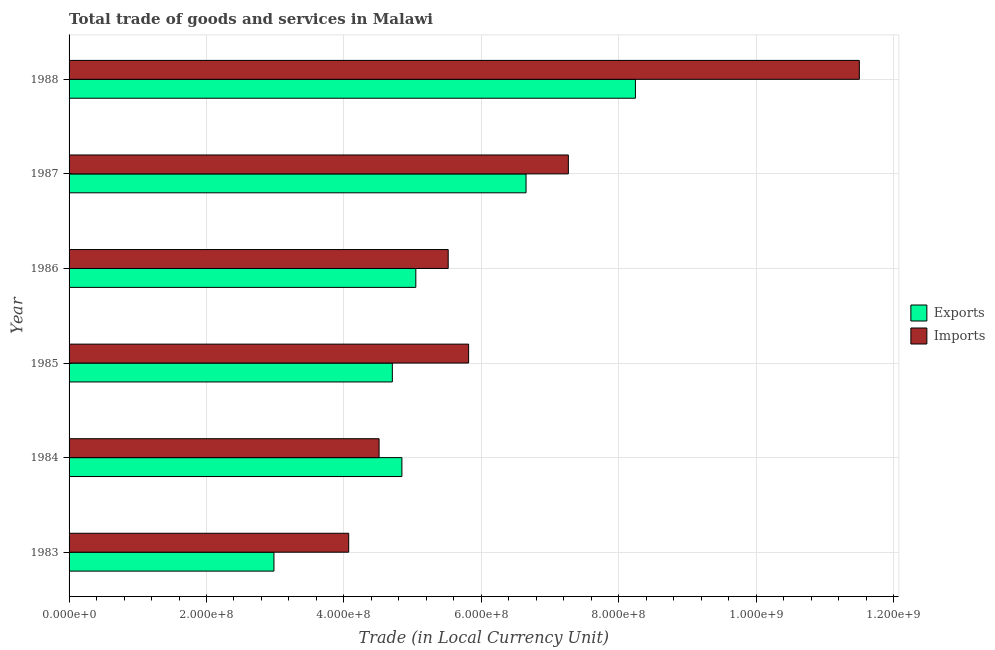Are the number of bars per tick equal to the number of legend labels?
Provide a short and direct response. Yes. Are the number of bars on each tick of the Y-axis equal?
Provide a succinct answer. Yes. How many bars are there on the 4th tick from the bottom?
Provide a succinct answer. 2. In how many cases, is the number of bars for a given year not equal to the number of legend labels?
Keep it short and to the point. 0. What is the imports of goods and services in 1987?
Your response must be concise. 7.27e+08. Across all years, what is the maximum imports of goods and services?
Provide a short and direct response. 1.15e+09. Across all years, what is the minimum export of goods and services?
Provide a succinct answer. 2.98e+08. What is the total imports of goods and services in the graph?
Provide a succinct answer. 3.87e+09. What is the difference between the imports of goods and services in 1987 and that in 1988?
Keep it short and to the point. -4.24e+08. What is the difference between the export of goods and services in 1987 and the imports of goods and services in 1984?
Keep it short and to the point. 2.14e+08. What is the average imports of goods and services per year?
Your answer should be compact. 6.45e+08. In the year 1983, what is the difference between the imports of goods and services and export of goods and services?
Keep it short and to the point. 1.09e+08. What is the ratio of the imports of goods and services in 1983 to that in 1987?
Provide a succinct answer. 0.56. Is the imports of goods and services in 1984 less than that in 1988?
Provide a succinct answer. Yes. What is the difference between the highest and the second highest imports of goods and services?
Your answer should be very brief. 4.24e+08. What is the difference between the highest and the lowest export of goods and services?
Your response must be concise. 5.26e+08. In how many years, is the imports of goods and services greater than the average imports of goods and services taken over all years?
Your answer should be very brief. 2. Is the sum of the export of goods and services in 1983 and 1988 greater than the maximum imports of goods and services across all years?
Give a very brief answer. No. What does the 2nd bar from the top in 1986 represents?
Offer a very short reply. Exports. What does the 2nd bar from the bottom in 1987 represents?
Your answer should be very brief. Imports. Are all the bars in the graph horizontal?
Provide a short and direct response. Yes. What is the difference between two consecutive major ticks on the X-axis?
Make the answer very short. 2.00e+08. Are the values on the major ticks of X-axis written in scientific E-notation?
Make the answer very short. Yes. How many legend labels are there?
Your answer should be very brief. 2. What is the title of the graph?
Offer a very short reply. Total trade of goods and services in Malawi. What is the label or title of the X-axis?
Your response must be concise. Trade (in Local Currency Unit). What is the Trade (in Local Currency Unit) in Exports in 1983?
Ensure brevity in your answer.  2.98e+08. What is the Trade (in Local Currency Unit) of Imports in 1983?
Provide a short and direct response. 4.07e+08. What is the Trade (in Local Currency Unit) of Exports in 1984?
Keep it short and to the point. 4.84e+08. What is the Trade (in Local Currency Unit) in Imports in 1984?
Make the answer very short. 4.51e+08. What is the Trade (in Local Currency Unit) of Exports in 1985?
Your response must be concise. 4.70e+08. What is the Trade (in Local Currency Unit) of Imports in 1985?
Provide a succinct answer. 5.82e+08. What is the Trade (in Local Currency Unit) in Exports in 1986?
Your answer should be very brief. 5.05e+08. What is the Trade (in Local Currency Unit) in Imports in 1986?
Provide a succinct answer. 5.52e+08. What is the Trade (in Local Currency Unit) of Exports in 1987?
Your response must be concise. 6.65e+08. What is the Trade (in Local Currency Unit) of Imports in 1987?
Provide a short and direct response. 7.27e+08. What is the Trade (in Local Currency Unit) of Exports in 1988?
Make the answer very short. 8.24e+08. What is the Trade (in Local Currency Unit) in Imports in 1988?
Provide a succinct answer. 1.15e+09. Across all years, what is the maximum Trade (in Local Currency Unit) of Exports?
Your response must be concise. 8.24e+08. Across all years, what is the maximum Trade (in Local Currency Unit) of Imports?
Ensure brevity in your answer.  1.15e+09. Across all years, what is the minimum Trade (in Local Currency Unit) in Exports?
Your answer should be compact. 2.98e+08. Across all years, what is the minimum Trade (in Local Currency Unit) in Imports?
Provide a succinct answer. 4.07e+08. What is the total Trade (in Local Currency Unit) of Exports in the graph?
Keep it short and to the point. 3.25e+09. What is the total Trade (in Local Currency Unit) of Imports in the graph?
Offer a very short reply. 3.87e+09. What is the difference between the Trade (in Local Currency Unit) in Exports in 1983 and that in 1984?
Provide a succinct answer. -1.86e+08. What is the difference between the Trade (in Local Currency Unit) of Imports in 1983 and that in 1984?
Offer a very short reply. -4.42e+07. What is the difference between the Trade (in Local Currency Unit) of Exports in 1983 and that in 1985?
Give a very brief answer. -1.72e+08. What is the difference between the Trade (in Local Currency Unit) in Imports in 1983 and that in 1985?
Provide a short and direct response. -1.74e+08. What is the difference between the Trade (in Local Currency Unit) in Exports in 1983 and that in 1986?
Give a very brief answer. -2.06e+08. What is the difference between the Trade (in Local Currency Unit) of Imports in 1983 and that in 1986?
Ensure brevity in your answer.  -1.45e+08. What is the difference between the Trade (in Local Currency Unit) of Exports in 1983 and that in 1987?
Give a very brief answer. -3.67e+08. What is the difference between the Trade (in Local Currency Unit) of Imports in 1983 and that in 1987?
Ensure brevity in your answer.  -3.20e+08. What is the difference between the Trade (in Local Currency Unit) of Exports in 1983 and that in 1988?
Your answer should be very brief. -5.26e+08. What is the difference between the Trade (in Local Currency Unit) in Imports in 1983 and that in 1988?
Your response must be concise. -7.43e+08. What is the difference between the Trade (in Local Currency Unit) in Exports in 1984 and that in 1985?
Ensure brevity in your answer.  1.39e+07. What is the difference between the Trade (in Local Currency Unit) in Imports in 1984 and that in 1985?
Provide a short and direct response. -1.30e+08. What is the difference between the Trade (in Local Currency Unit) of Exports in 1984 and that in 1986?
Offer a very short reply. -2.03e+07. What is the difference between the Trade (in Local Currency Unit) in Imports in 1984 and that in 1986?
Keep it short and to the point. -1.01e+08. What is the difference between the Trade (in Local Currency Unit) of Exports in 1984 and that in 1987?
Offer a very short reply. -1.81e+08. What is the difference between the Trade (in Local Currency Unit) of Imports in 1984 and that in 1987?
Keep it short and to the point. -2.76e+08. What is the difference between the Trade (in Local Currency Unit) in Exports in 1984 and that in 1988?
Your answer should be compact. -3.40e+08. What is the difference between the Trade (in Local Currency Unit) of Imports in 1984 and that in 1988?
Provide a short and direct response. -6.99e+08. What is the difference between the Trade (in Local Currency Unit) in Exports in 1985 and that in 1986?
Keep it short and to the point. -3.42e+07. What is the difference between the Trade (in Local Currency Unit) of Imports in 1985 and that in 1986?
Offer a terse response. 2.97e+07. What is the difference between the Trade (in Local Currency Unit) of Exports in 1985 and that in 1987?
Your response must be concise. -1.95e+08. What is the difference between the Trade (in Local Currency Unit) in Imports in 1985 and that in 1987?
Make the answer very short. -1.45e+08. What is the difference between the Trade (in Local Currency Unit) in Exports in 1985 and that in 1988?
Your response must be concise. -3.54e+08. What is the difference between the Trade (in Local Currency Unit) in Imports in 1985 and that in 1988?
Provide a succinct answer. -5.69e+08. What is the difference between the Trade (in Local Currency Unit) of Exports in 1986 and that in 1987?
Give a very brief answer. -1.60e+08. What is the difference between the Trade (in Local Currency Unit) in Imports in 1986 and that in 1987?
Your answer should be compact. -1.75e+08. What is the difference between the Trade (in Local Currency Unit) in Exports in 1986 and that in 1988?
Your answer should be compact. -3.20e+08. What is the difference between the Trade (in Local Currency Unit) of Imports in 1986 and that in 1988?
Offer a terse response. -5.98e+08. What is the difference between the Trade (in Local Currency Unit) of Exports in 1987 and that in 1988?
Provide a short and direct response. -1.59e+08. What is the difference between the Trade (in Local Currency Unit) of Imports in 1987 and that in 1988?
Provide a short and direct response. -4.24e+08. What is the difference between the Trade (in Local Currency Unit) of Exports in 1983 and the Trade (in Local Currency Unit) of Imports in 1984?
Make the answer very short. -1.53e+08. What is the difference between the Trade (in Local Currency Unit) of Exports in 1983 and the Trade (in Local Currency Unit) of Imports in 1985?
Make the answer very short. -2.83e+08. What is the difference between the Trade (in Local Currency Unit) in Exports in 1983 and the Trade (in Local Currency Unit) in Imports in 1986?
Your answer should be compact. -2.54e+08. What is the difference between the Trade (in Local Currency Unit) in Exports in 1983 and the Trade (in Local Currency Unit) in Imports in 1987?
Provide a succinct answer. -4.28e+08. What is the difference between the Trade (in Local Currency Unit) of Exports in 1983 and the Trade (in Local Currency Unit) of Imports in 1988?
Give a very brief answer. -8.52e+08. What is the difference between the Trade (in Local Currency Unit) of Exports in 1984 and the Trade (in Local Currency Unit) of Imports in 1985?
Your answer should be very brief. -9.71e+07. What is the difference between the Trade (in Local Currency Unit) of Exports in 1984 and the Trade (in Local Currency Unit) of Imports in 1986?
Give a very brief answer. -6.74e+07. What is the difference between the Trade (in Local Currency Unit) in Exports in 1984 and the Trade (in Local Currency Unit) in Imports in 1987?
Your answer should be very brief. -2.42e+08. What is the difference between the Trade (in Local Currency Unit) in Exports in 1984 and the Trade (in Local Currency Unit) in Imports in 1988?
Offer a very short reply. -6.66e+08. What is the difference between the Trade (in Local Currency Unit) of Exports in 1985 and the Trade (in Local Currency Unit) of Imports in 1986?
Give a very brief answer. -8.13e+07. What is the difference between the Trade (in Local Currency Unit) in Exports in 1985 and the Trade (in Local Currency Unit) in Imports in 1987?
Your answer should be very brief. -2.56e+08. What is the difference between the Trade (in Local Currency Unit) in Exports in 1985 and the Trade (in Local Currency Unit) in Imports in 1988?
Provide a succinct answer. -6.80e+08. What is the difference between the Trade (in Local Currency Unit) in Exports in 1986 and the Trade (in Local Currency Unit) in Imports in 1987?
Ensure brevity in your answer.  -2.22e+08. What is the difference between the Trade (in Local Currency Unit) of Exports in 1986 and the Trade (in Local Currency Unit) of Imports in 1988?
Keep it short and to the point. -6.46e+08. What is the difference between the Trade (in Local Currency Unit) in Exports in 1987 and the Trade (in Local Currency Unit) in Imports in 1988?
Offer a very short reply. -4.85e+08. What is the average Trade (in Local Currency Unit) of Exports per year?
Offer a terse response. 5.41e+08. What is the average Trade (in Local Currency Unit) of Imports per year?
Ensure brevity in your answer.  6.45e+08. In the year 1983, what is the difference between the Trade (in Local Currency Unit) of Exports and Trade (in Local Currency Unit) of Imports?
Ensure brevity in your answer.  -1.09e+08. In the year 1984, what is the difference between the Trade (in Local Currency Unit) of Exports and Trade (in Local Currency Unit) of Imports?
Provide a succinct answer. 3.32e+07. In the year 1985, what is the difference between the Trade (in Local Currency Unit) in Exports and Trade (in Local Currency Unit) in Imports?
Offer a very short reply. -1.11e+08. In the year 1986, what is the difference between the Trade (in Local Currency Unit) of Exports and Trade (in Local Currency Unit) of Imports?
Your answer should be very brief. -4.71e+07. In the year 1987, what is the difference between the Trade (in Local Currency Unit) of Exports and Trade (in Local Currency Unit) of Imports?
Provide a short and direct response. -6.16e+07. In the year 1988, what is the difference between the Trade (in Local Currency Unit) of Exports and Trade (in Local Currency Unit) of Imports?
Make the answer very short. -3.26e+08. What is the ratio of the Trade (in Local Currency Unit) in Exports in 1983 to that in 1984?
Offer a very short reply. 0.62. What is the ratio of the Trade (in Local Currency Unit) of Imports in 1983 to that in 1984?
Provide a short and direct response. 0.9. What is the ratio of the Trade (in Local Currency Unit) in Exports in 1983 to that in 1985?
Offer a terse response. 0.63. What is the ratio of the Trade (in Local Currency Unit) in Imports in 1983 to that in 1985?
Keep it short and to the point. 0.7. What is the ratio of the Trade (in Local Currency Unit) in Exports in 1983 to that in 1986?
Provide a short and direct response. 0.59. What is the ratio of the Trade (in Local Currency Unit) of Imports in 1983 to that in 1986?
Provide a succinct answer. 0.74. What is the ratio of the Trade (in Local Currency Unit) in Exports in 1983 to that in 1987?
Your answer should be compact. 0.45. What is the ratio of the Trade (in Local Currency Unit) of Imports in 1983 to that in 1987?
Keep it short and to the point. 0.56. What is the ratio of the Trade (in Local Currency Unit) of Exports in 1983 to that in 1988?
Provide a short and direct response. 0.36. What is the ratio of the Trade (in Local Currency Unit) of Imports in 1983 to that in 1988?
Provide a short and direct response. 0.35. What is the ratio of the Trade (in Local Currency Unit) in Exports in 1984 to that in 1985?
Provide a succinct answer. 1.03. What is the ratio of the Trade (in Local Currency Unit) in Imports in 1984 to that in 1985?
Your answer should be very brief. 0.78. What is the ratio of the Trade (in Local Currency Unit) in Exports in 1984 to that in 1986?
Your response must be concise. 0.96. What is the ratio of the Trade (in Local Currency Unit) in Imports in 1984 to that in 1986?
Ensure brevity in your answer.  0.82. What is the ratio of the Trade (in Local Currency Unit) in Exports in 1984 to that in 1987?
Make the answer very short. 0.73. What is the ratio of the Trade (in Local Currency Unit) of Imports in 1984 to that in 1987?
Give a very brief answer. 0.62. What is the ratio of the Trade (in Local Currency Unit) in Exports in 1984 to that in 1988?
Give a very brief answer. 0.59. What is the ratio of the Trade (in Local Currency Unit) of Imports in 1984 to that in 1988?
Your response must be concise. 0.39. What is the ratio of the Trade (in Local Currency Unit) in Exports in 1985 to that in 1986?
Ensure brevity in your answer.  0.93. What is the ratio of the Trade (in Local Currency Unit) in Imports in 1985 to that in 1986?
Offer a terse response. 1.05. What is the ratio of the Trade (in Local Currency Unit) in Exports in 1985 to that in 1987?
Your response must be concise. 0.71. What is the ratio of the Trade (in Local Currency Unit) in Imports in 1985 to that in 1987?
Offer a very short reply. 0.8. What is the ratio of the Trade (in Local Currency Unit) in Exports in 1985 to that in 1988?
Your answer should be very brief. 0.57. What is the ratio of the Trade (in Local Currency Unit) in Imports in 1985 to that in 1988?
Make the answer very short. 0.51. What is the ratio of the Trade (in Local Currency Unit) of Exports in 1986 to that in 1987?
Give a very brief answer. 0.76. What is the ratio of the Trade (in Local Currency Unit) in Imports in 1986 to that in 1987?
Give a very brief answer. 0.76. What is the ratio of the Trade (in Local Currency Unit) of Exports in 1986 to that in 1988?
Ensure brevity in your answer.  0.61. What is the ratio of the Trade (in Local Currency Unit) of Imports in 1986 to that in 1988?
Give a very brief answer. 0.48. What is the ratio of the Trade (in Local Currency Unit) of Exports in 1987 to that in 1988?
Your answer should be very brief. 0.81. What is the ratio of the Trade (in Local Currency Unit) in Imports in 1987 to that in 1988?
Provide a short and direct response. 0.63. What is the difference between the highest and the second highest Trade (in Local Currency Unit) of Exports?
Your response must be concise. 1.59e+08. What is the difference between the highest and the second highest Trade (in Local Currency Unit) in Imports?
Your answer should be compact. 4.24e+08. What is the difference between the highest and the lowest Trade (in Local Currency Unit) in Exports?
Offer a terse response. 5.26e+08. What is the difference between the highest and the lowest Trade (in Local Currency Unit) in Imports?
Offer a terse response. 7.43e+08. 